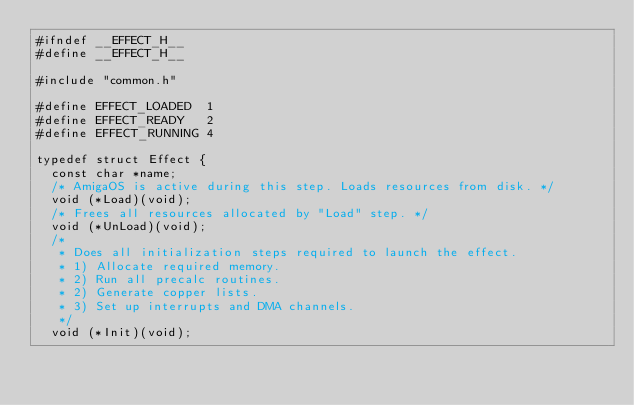Convert code to text. <code><loc_0><loc_0><loc_500><loc_500><_C_>#ifndef __EFFECT_H__
#define __EFFECT_H__

#include "common.h"

#define EFFECT_LOADED  1
#define EFFECT_READY   2
#define EFFECT_RUNNING 4

typedef struct Effect {
  const char *name;
  /* AmigaOS is active during this step. Loads resources from disk. */
  void (*Load)(void);
  /* Frees all resources allocated by "Load" step. */
  void (*UnLoad)(void);
  /*
   * Does all initialization steps required to launch the effect.
   * 1) Allocate required memory.
   * 2) Run all precalc routines.
   * 2) Generate copper lists.
   * 3) Set up interrupts and DMA channels.
   */
  void (*Init)(void);</code> 